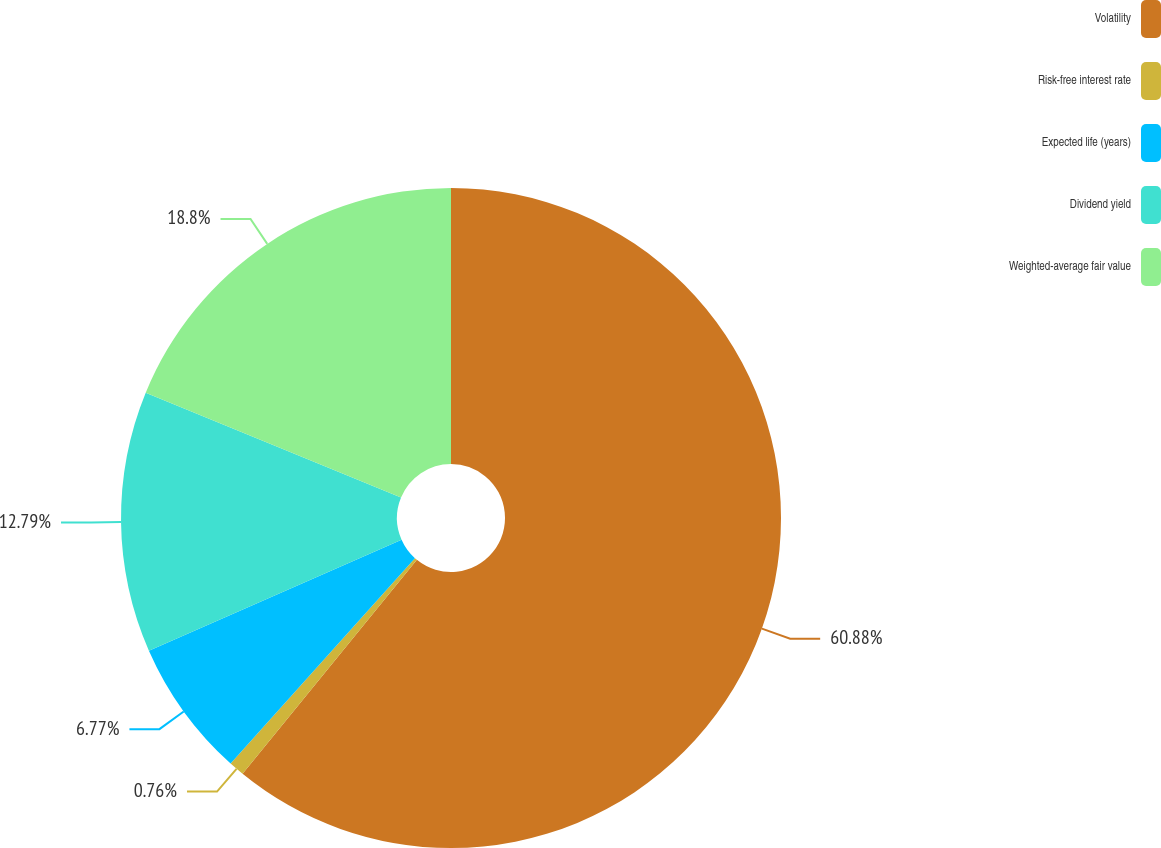Convert chart. <chart><loc_0><loc_0><loc_500><loc_500><pie_chart><fcel>Volatility<fcel>Risk-free interest rate<fcel>Expected life (years)<fcel>Dividend yield<fcel>Weighted-average fair value<nl><fcel>60.88%<fcel>0.76%<fcel>6.77%<fcel>12.79%<fcel>18.8%<nl></chart> 